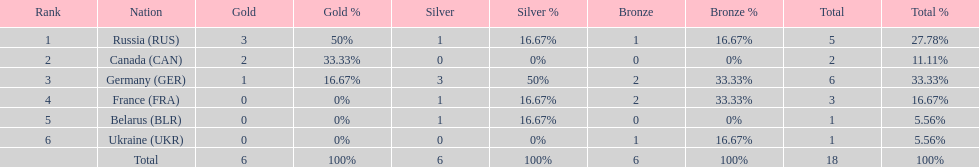What was the total number of silver medals awarded to the french and the germans in the 1994 winter olympic biathlon? 4. 